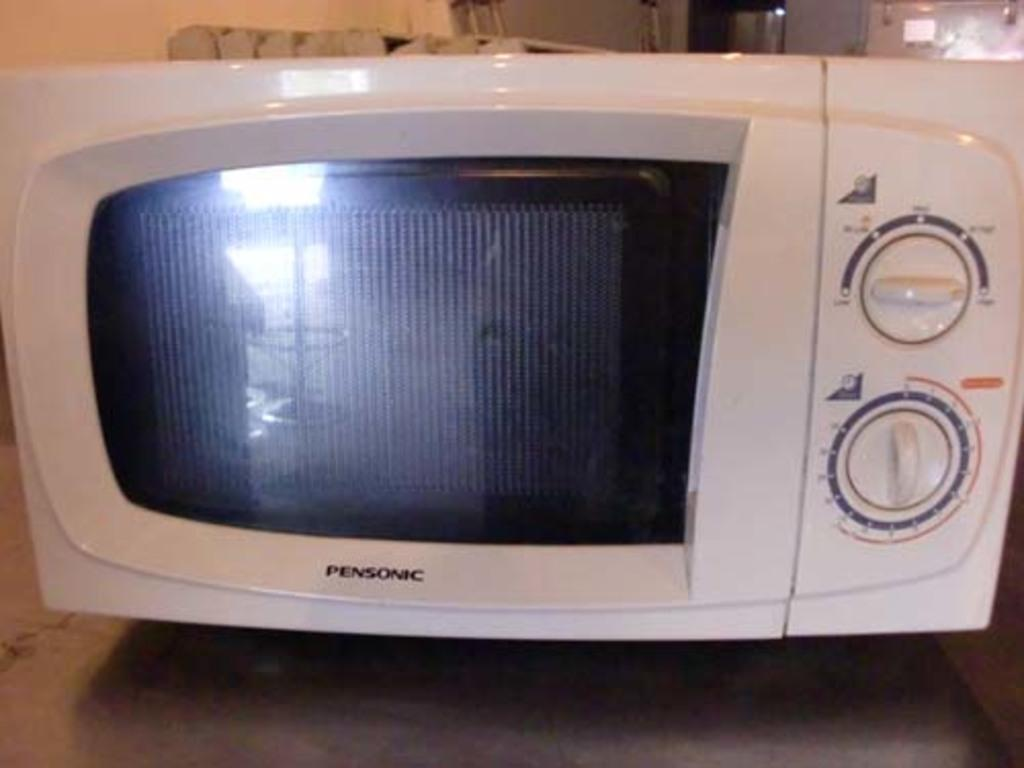Provide a one-sentence caption for the provided image. A Pensonic microwave with manual dials instead of buttons. 